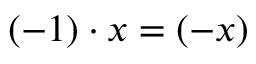<formula> <loc_0><loc_0><loc_500><loc_500>( - 1 ) \cdot x = ( - x )</formula> 